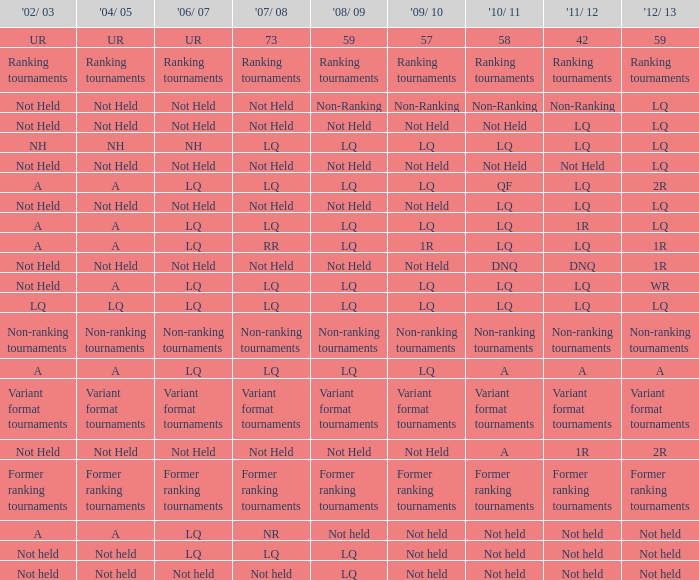Name the 2008/09 with 2004/05 of ranking tournaments Ranking tournaments. 